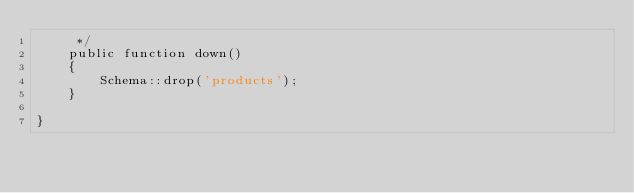Convert code to text. <code><loc_0><loc_0><loc_500><loc_500><_PHP_>     */
    public function down()
    {
        Schema::drop('products');
    }

}
</code> 